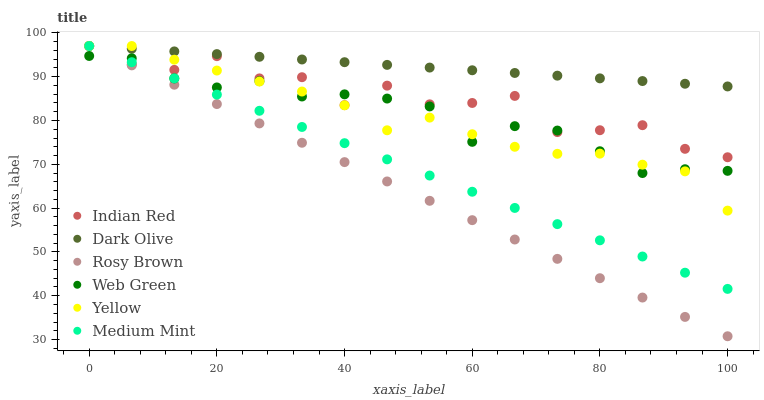Does Rosy Brown have the minimum area under the curve?
Answer yes or no. Yes. Does Dark Olive have the maximum area under the curve?
Answer yes or no. Yes. Does Dark Olive have the minimum area under the curve?
Answer yes or no. No. Does Rosy Brown have the maximum area under the curve?
Answer yes or no. No. Is Medium Mint the smoothest?
Answer yes or no. Yes. Is Indian Red the roughest?
Answer yes or no. Yes. Is Dark Olive the smoothest?
Answer yes or no. No. Is Dark Olive the roughest?
Answer yes or no. No. Does Rosy Brown have the lowest value?
Answer yes or no. Yes. Does Dark Olive have the lowest value?
Answer yes or no. No. Does Indian Red have the highest value?
Answer yes or no. Yes. Does Web Green have the highest value?
Answer yes or no. No. Is Web Green less than Dark Olive?
Answer yes or no. Yes. Is Dark Olive greater than Web Green?
Answer yes or no. Yes. Does Web Green intersect Rosy Brown?
Answer yes or no. Yes. Is Web Green less than Rosy Brown?
Answer yes or no. No. Is Web Green greater than Rosy Brown?
Answer yes or no. No. Does Web Green intersect Dark Olive?
Answer yes or no. No. 